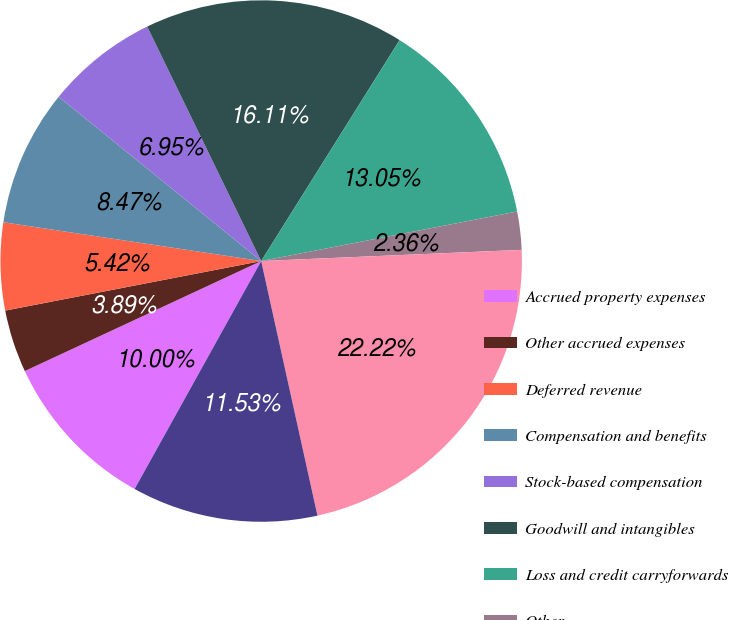<chart> <loc_0><loc_0><loc_500><loc_500><pie_chart><fcel>Accrued property expenses<fcel>Other accrued expenses<fcel>Deferred revenue<fcel>Compensation and benefits<fcel>Stock-based compensation<fcel>Goodwill and intangibles<fcel>Loss and credit carryforwards<fcel>Other<fcel>Total deferred tax assets<fcel>Valuation allowance<nl><fcel>10.0%<fcel>3.89%<fcel>5.42%<fcel>8.47%<fcel>6.95%<fcel>16.11%<fcel>13.05%<fcel>2.36%<fcel>22.22%<fcel>11.53%<nl></chart> 